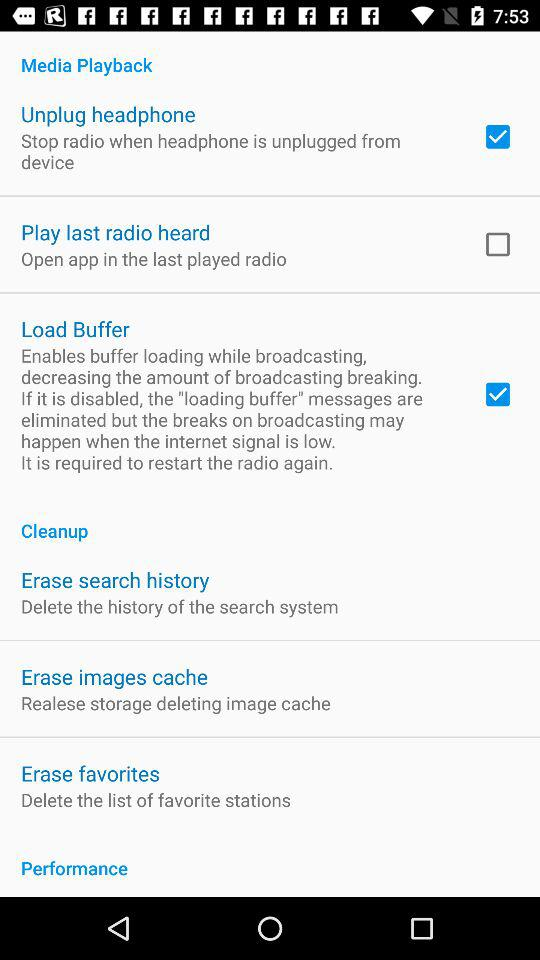Is "Unplug headphone" disabled or enabled? "Unplug headphone" is enabled. 